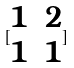<formula> <loc_0><loc_0><loc_500><loc_500>[ \begin{matrix} 1 & 2 \\ 1 & 1 \end{matrix} ]</formula> 